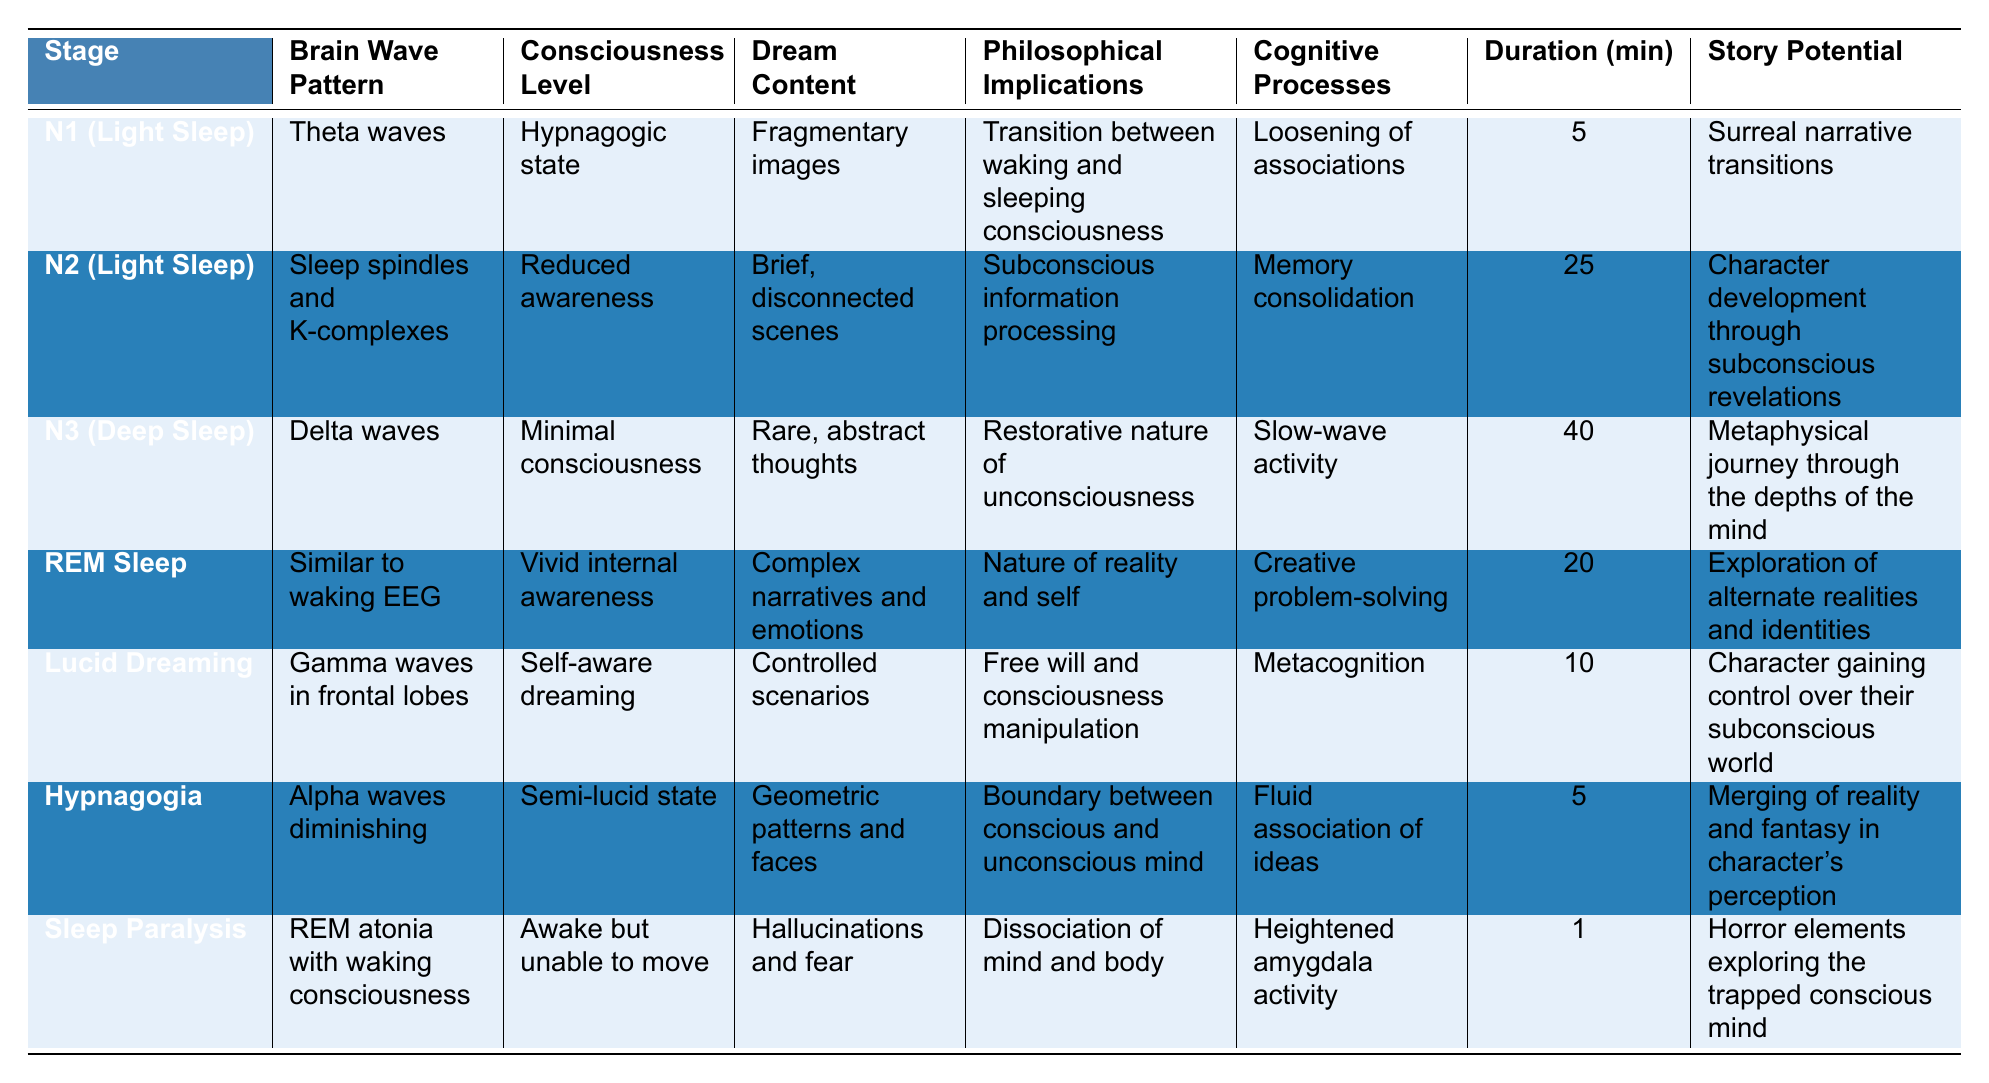What is the duration of REM sleep? According to the table, REM sleep lasts for 20 minutes as indicated in the "Duration (min)" column for that stage.
Answer: 20 minutes Which sleep stage has the highest consciousness level? The sleep stage with the highest consciousness level is "REM Sleep," which has a level of "Vivid internal awareness" listed in that category.
Answer: REM Sleep How many sleep cycles last less than 10 minutes? The sleep stages that last less than 10 minutes are N1 (5 minutes), Hypnagogia (5 minutes), and Sleep Paralysis (1 minute). Thus, there are three sleep cycles under 10 minutes.
Answer: 3 What philosophical implication is associated with N3 (Deep Sleep)? The philosophical implication associated with N3 (Deep Sleep) is "Restorative nature of unconsciousness," as stated in the table.
Answer: Restorative nature of unconsciousness Which sleep stage is characterized by "Controlled scenarios"? "Lucid Dreaming" is characterized by "Controlled scenarios" as mentioned in the dream content for that stage in the table.
Answer: Lucid Dreaming What is the total duration of light sleep stages (N1 and N2)? The total duration of the light sleep stages N1 and N2 is calculated as N1 (5 minutes) + N2 (25 minutes) = 30 minutes.
Answer: 30 minutes Is the dream content during Sleep Paralysis typically pleasant? The table indicates that the dream content during Sleep Paralysis consists of "Hallucinations and fear," which suggests that it is not pleasant.
Answer: No Which sleep stage involves the brain wave pattern of gamma waves? The brain wave pattern of gamma waves is associated with "Lucid Dreaming," as per the data in the table.
Answer: Lucid Dreaming What does the cognitive process of "Metacognition" refer to in the context of sleep stages? "Metacognition" is the cognitive process linked with "Lucid Dreaming," indicating awareness and control over one's thought processes during that sleep stage.
Answer: Awareness and control of thoughts How does the consciousness level change from N1 to N3? The consciousness level transitions from "Hypnagogic state" in N1 to "Minimal consciousness" in N3, indicating a decrease in awareness as one progresses deeper into sleep.
Answer: Decrease in awareness 